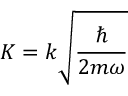<formula> <loc_0><loc_0><loc_500><loc_500>{ K = k \sqrt { \frac { } { 2 m \omega } } }</formula> 